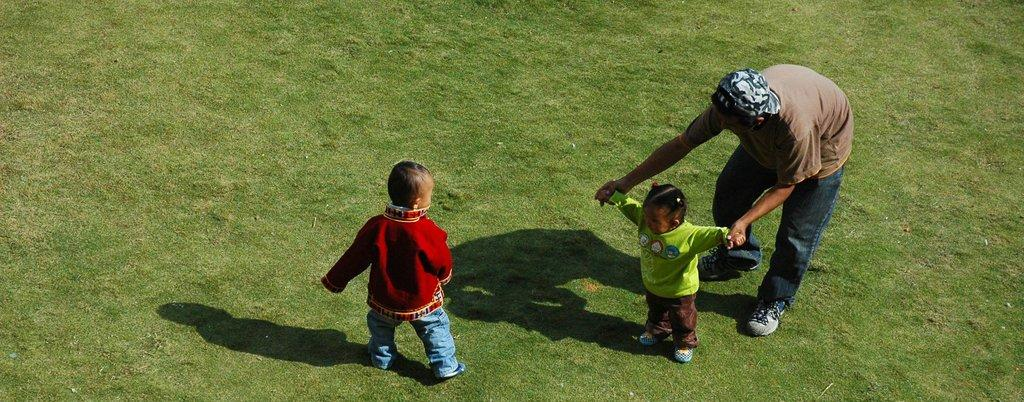What is happening in the center of the image? There are persons standing in the center of the image. What type of surface is under the persons' feet? There is grass on the ground in the image. What does the aunt desire to do in the image? There is no aunt present in the image, so it is not possible to determine what they might desire to do. 